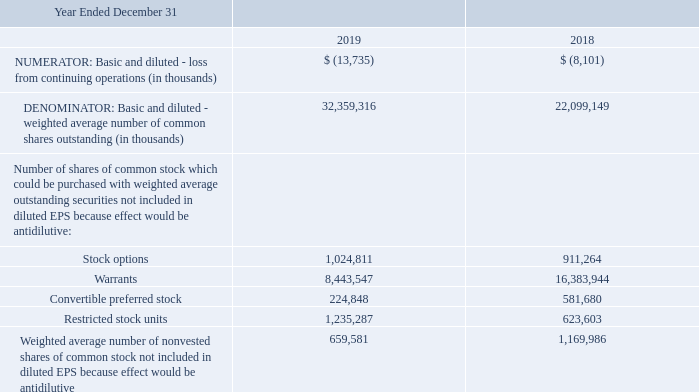NOTE 14. INCOME (LOSS) PER SHARE (EPS)
Basic EPS is calculated under the two-class method under which all earnings (distributed and undistributed) are allocated to each class of common stock and participating securities based on their respective rights to receive dividends. Our outstanding convertible preferred stocks are considered participating securities as the holders may participate in undistributed earnings with holders of common shares and are not obligated to share in our net losses.
Diluted EPS is computed by dividing the net income attributable to RiceBran Technologies common shareholders by the weighted average number of common shares outstanding during the period increased by the number of additional common shares that would have been outstanding if the impact of assumed exercises and conversions is dilutive. The dilutive effects of outstanding options, warrants, nonvested shares and restricted stock units that vest solely on the basis of a service condition are calculated using the treasury stock method. The dilutive effects of the outstanding preferred stock are calculated using the if-converted method.
Below are reconciliations of the numerators and denominators in the EPS computations, and information on potentially dilutive securities.
The impacts of potentially dilutive securities outstanding at December 31, 2019 and 2018, were not included in the calculation of diluted EPS in 2019 and 2018 because to do so would be anti-dilutive. Those securities listed in the table above which were anti-dilutive in 2019 and 2018, which remain outstanding, could potentially dilute EPS in the future.
What are the respective basic and diluted - loss from continuing operations in 2018 and 2019?
Answer scale should be: thousand. 8,101, 13,735. What are the respective basic and diluted - weighted average number of common shares outstanding in 2018 and 2019?
Answer scale should be: thousand. 22,099,149, 32,359,316. What are the respective number of stock options in 2018 and 2019?
Answer scale should be: thousand. 911,264, 1,024,811. What is the average number of stock options between 2018 and 2019? (911,264 + 1,024,811)/2 
Answer: 968037.5. What is the average number of warrants between 2018 and 2019? (16,383,944 + 8,443,547)/2 
Answer: 12413745.5. What is the average number of restricted stock units in 2018 and 2019? (623,603 + 1,235,287)/2 
Answer: 929445. 